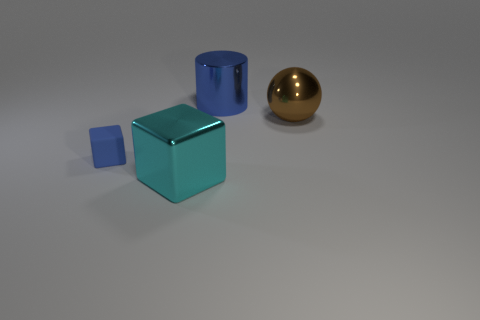Add 4 big spheres. How many objects exist? 8 Subtract all balls. How many objects are left? 3 Subtract all small yellow metal spheres. Subtract all big blue shiny cylinders. How many objects are left? 3 Add 1 large cyan objects. How many large cyan objects are left? 2 Add 3 small gray rubber spheres. How many small gray rubber spheres exist? 3 Subtract 1 blue cylinders. How many objects are left? 3 